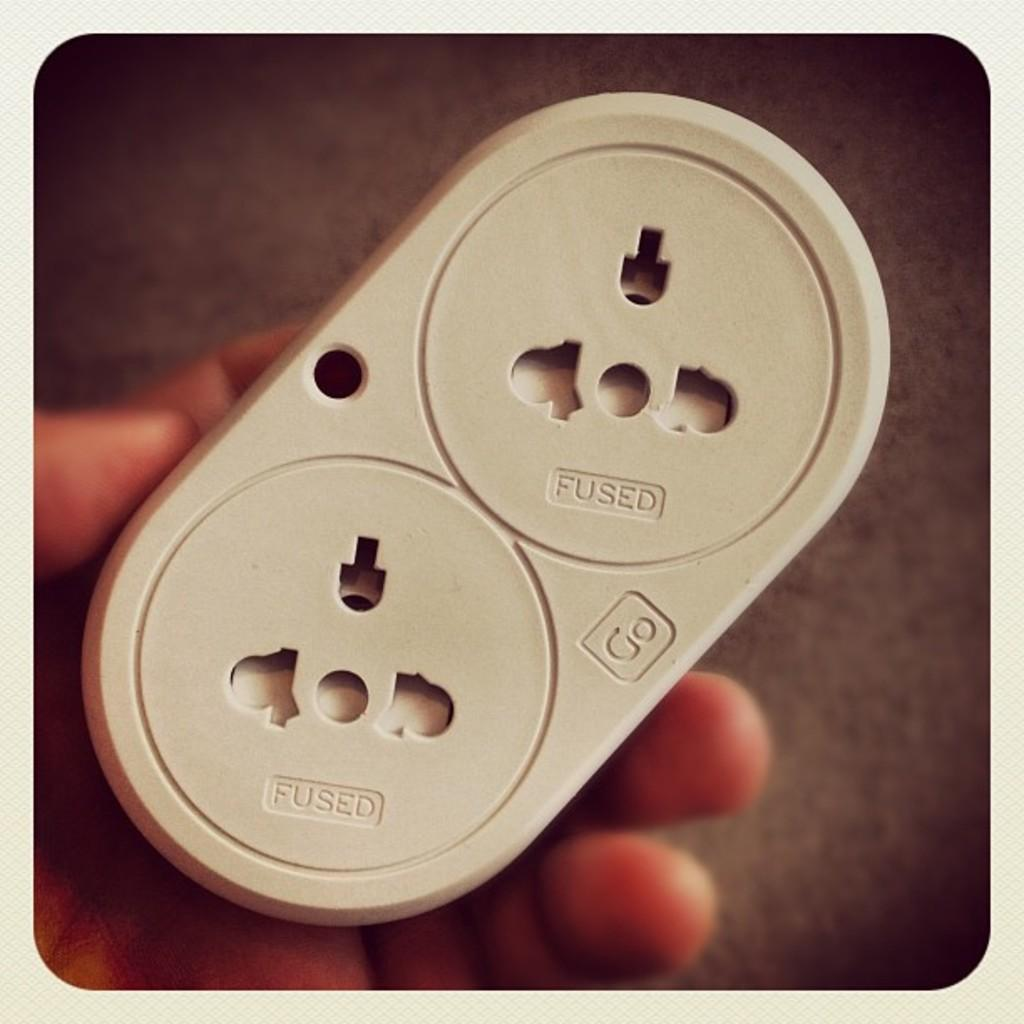<image>
Provide a brief description of the given image. A plastic item held in a hand says fused on each end. 